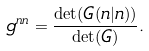Convert formula to latex. <formula><loc_0><loc_0><loc_500><loc_500>g ^ { n n } = \frac { \det ( G ( n | n ) ) } { \det ( G ) } .</formula> 